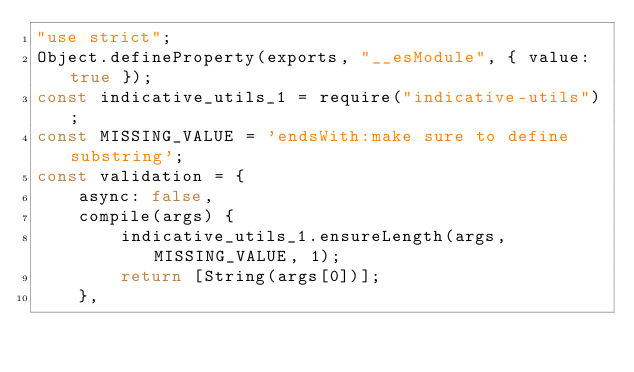Convert code to text. <code><loc_0><loc_0><loc_500><loc_500><_JavaScript_>"use strict";
Object.defineProperty(exports, "__esModule", { value: true });
const indicative_utils_1 = require("indicative-utils");
const MISSING_VALUE = 'endsWith:make sure to define substring';
const validation = {
    async: false,
    compile(args) {
        indicative_utils_1.ensureLength(args, MISSING_VALUE, 1);
        return [String(args[0])];
    },</code> 